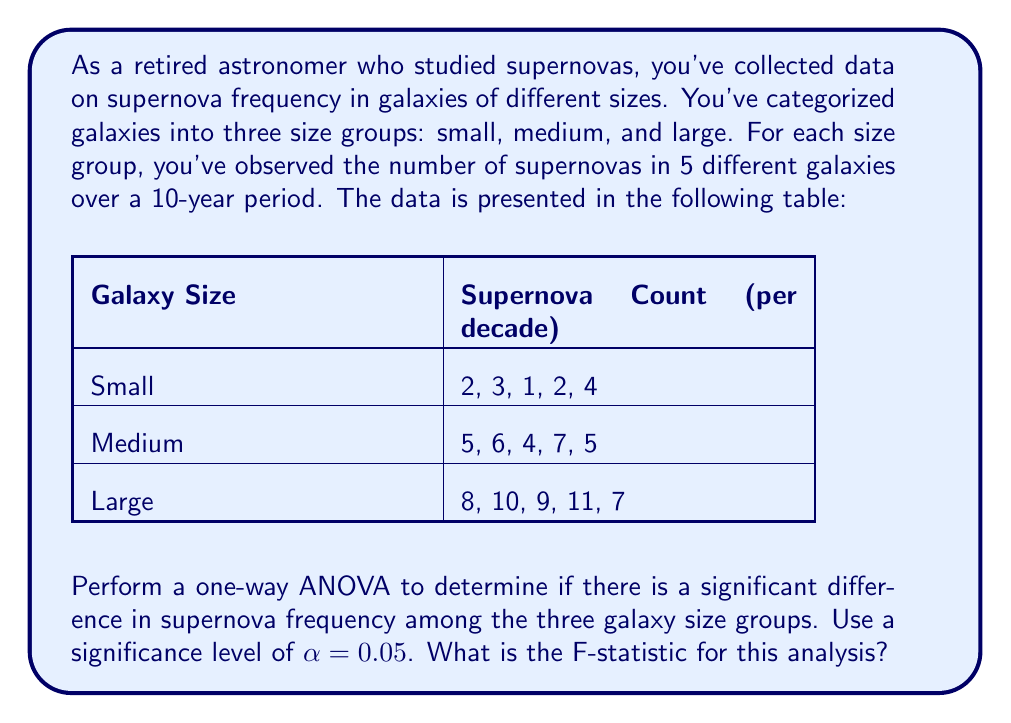Can you answer this question? Let's perform the one-way ANOVA step-by-step:

1) First, calculate the means for each group:
   Small: $\bar{X}_1 = (2 + 3 + 1 + 2 + 4) / 5 = 2.4$
   Medium: $\bar{X}_2 = (5 + 6 + 4 + 7 + 5) / 5 = 5.4$
   Large: $\bar{X}_3 = (8 + 10 + 9 + 11 + 7) / 5 = 9$

2) Calculate the grand mean:
   $\bar{X} = (2.4 + 5.4 + 9) / 3 = 5.6$

3) Calculate SSB (Sum of Squares Between groups):
   $$SSB = 5[(2.4 - 5.6)^2 + (5.4 - 5.6)^2 + (9 - 5.6)^2] = 136.8$$

4) Calculate SSW (Sum of Squares Within groups):
   Small: $\sum(X - \bar{X}_1)^2 = (2-2.4)^2 + (3-2.4)^2 + (1-2.4)^2 + (2-2.4)^2 + (4-2.4)^2 = 5.2$
   Medium: $\sum(X - \bar{X}_2)^2 = (5-5.4)^2 + (6-5.4)^2 + (4-5.4)^2 + (7-5.4)^2 + (5-5.4)^2 = 5.2$
   Large: $\sum(X - \bar{X}_3)^2 = (8-9)^2 + (10-9)^2 + (9-9)^2 + (11-9)^2 + (7-9)^2 = 10$
   
   $$SSW = 5.2 + 5.2 + 10 = 20.4$$

5) Calculate degrees of freedom:
   dfB (between groups) = 3 - 1 = 2
   dfW (within groups) = 15 - 3 = 12

6) Calculate Mean Square Between (MSB) and Mean Square Within (MSW):
   $$MSB = SSB / dfB = 136.8 / 2 = 68.4$$
   $$MSW = SSW / dfW = 20.4 / 12 = 1.7$$

7) Calculate the F-statistic:
   $$F = MSB / MSW = 68.4 / 1.7 = 40.24$$

Thus, the F-statistic for this analysis is 40.24.
Answer: $F = 40.24$ 